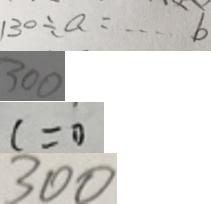<formula> <loc_0><loc_0><loc_500><loc_500>1 3 0 \div a = \cdots b 
 3 0 0 
 c = 0 
 3 0 0</formula> 